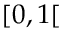Convert formula to latex. <formula><loc_0><loc_0><loc_500><loc_500>[ 0 , 1 [</formula> 